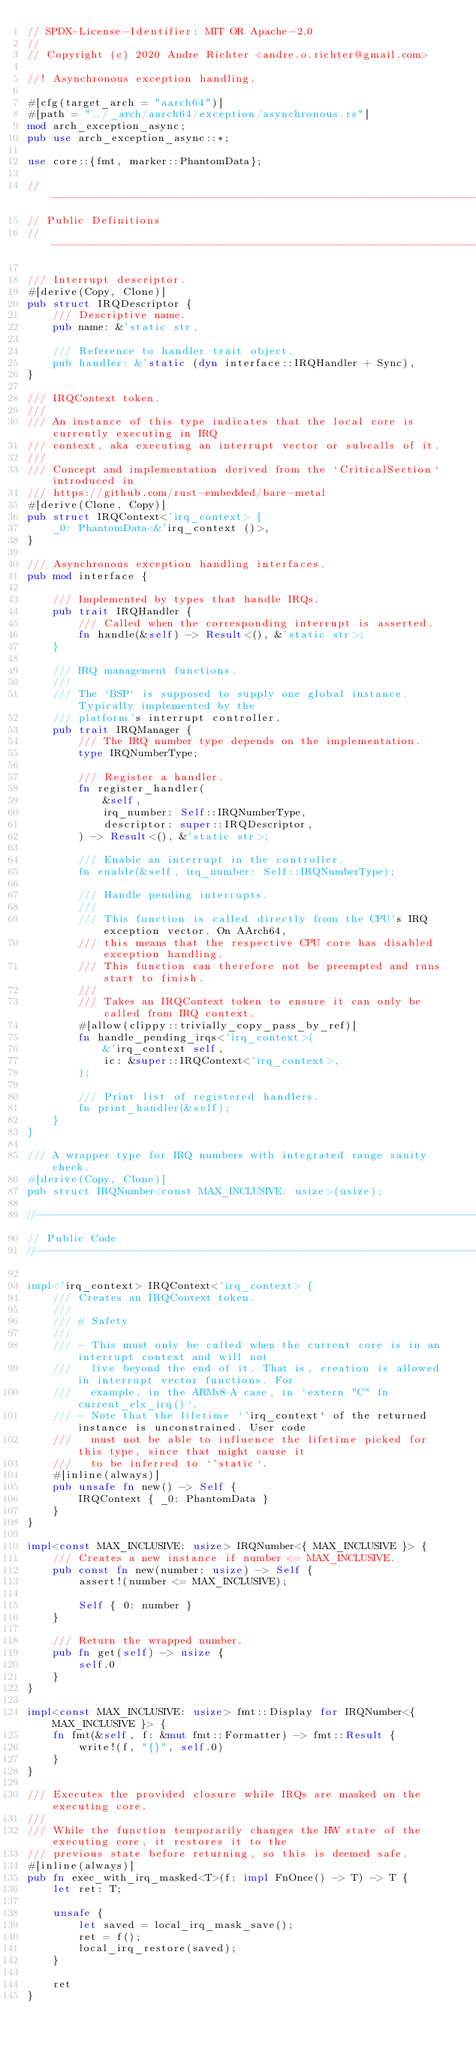Convert code to text. <code><loc_0><loc_0><loc_500><loc_500><_Rust_>// SPDX-License-Identifier: MIT OR Apache-2.0
//
// Copyright (c) 2020 Andre Richter <andre.o.richter@gmail.com>

//! Asynchronous exception handling.

#[cfg(target_arch = "aarch64")]
#[path = "../_arch/aarch64/exception/asynchronous.rs"]
mod arch_exception_async;
pub use arch_exception_async::*;

use core::{fmt, marker::PhantomData};

//--------------------------------------------------------------------------------------------------
// Public Definitions
//--------------------------------------------------------------------------------------------------

/// Interrupt descriptor.
#[derive(Copy, Clone)]
pub struct IRQDescriptor {
    /// Descriptive name.
    pub name: &'static str,

    /// Reference to handler trait object.
    pub handler: &'static (dyn interface::IRQHandler + Sync),
}

/// IRQContext token.
///
/// An instance of this type indicates that the local core is currently executing in IRQ
/// context, aka executing an interrupt vector or subcalls of it.
///
/// Concept and implementation derived from the `CriticalSection` introduced in
/// https://github.com/rust-embedded/bare-metal
#[derive(Clone, Copy)]
pub struct IRQContext<'irq_context> {
    _0: PhantomData<&'irq_context ()>,
}

/// Asynchronous exception handling interfaces.
pub mod interface {

    /// Implemented by types that handle IRQs.
    pub trait IRQHandler {
        /// Called when the corresponding interrupt is asserted.
        fn handle(&self) -> Result<(), &'static str>;
    }

    /// IRQ management functions.
    ///
    /// The `BSP` is supposed to supply one global instance. Typically implemented by the
    /// platform's interrupt controller.
    pub trait IRQManager {
        /// The IRQ number type depends on the implementation.
        type IRQNumberType;

        /// Register a handler.
        fn register_handler(
            &self,
            irq_number: Self::IRQNumberType,
            descriptor: super::IRQDescriptor,
        ) -> Result<(), &'static str>;

        /// Enable an interrupt in the controller.
        fn enable(&self, irq_number: Self::IRQNumberType);

        /// Handle pending interrupts.
        ///
        /// This function is called directly from the CPU's IRQ exception vector. On AArch64,
        /// this means that the respective CPU core has disabled exception handling.
        /// This function can therefore not be preempted and runs start to finish.
        ///
        /// Takes an IRQContext token to ensure it can only be called from IRQ context.
        #[allow(clippy::trivially_copy_pass_by_ref)]
        fn handle_pending_irqs<'irq_context>(
            &'irq_context self,
            ic: &super::IRQContext<'irq_context>,
        );

        /// Print list of registered handlers.
        fn print_handler(&self);
    }
}

/// A wrapper type for IRQ numbers with integrated range sanity check.
#[derive(Copy, Clone)]
pub struct IRQNumber<const MAX_INCLUSIVE: usize>(usize);

//--------------------------------------------------------------------------------------------------
// Public Code
//--------------------------------------------------------------------------------------------------

impl<'irq_context> IRQContext<'irq_context> {
    /// Creates an IRQContext token.
    ///
    /// # Safety
    ///
    /// - This must only be called when the current core is in an interrupt context and will not
    ///   live beyond the end of it. That is, creation is allowed in interrupt vector functions. For
    ///   example, in the ARMv8-A case, in `extern "C" fn current_elx_irq()`.
    /// - Note that the lifetime `'irq_context` of the returned instance is unconstrained. User code
    ///   must not be able to influence the lifetime picked for this type, since that might cause it
    ///   to be inferred to `'static`.
    #[inline(always)]
    pub unsafe fn new() -> Self {
        IRQContext { _0: PhantomData }
    }
}

impl<const MAX_INCLUSIVE: usize> IRQNumber<{ MAX_INCLUSIVE }> {
    /// Creates a new instance if number <= MAX_INCLUSIVE.
    pub const fn new(number: usize) -> Self {
        assert!(number <= MAX_INCLUSIVE);

        Self { 0: number }
    }

    /// Return the wrapped number.
    pub fn get(self) -> usize {
        self.0
    }
}

impl<const MAX_INCLUSIVE: usize> fmt::Display for IRQNumber<{ MAX_INCLUSIVE }> {
    fn fmt(&self, f: &mut fmt::Formatter) -> fmt::Result {
        write!(f, "{}", self.0)
    }
}

/// Executes the provided closure while IRQs are masked on the executing core.
///
/// While the function temporarily changes the HW state of the executing core, it restores it to the
/// previous state before returning, so this is deemed safe.
#[inline(always)]
pub fn exec_with_irq_masked<T>(f: impl FnOnce() -> T) -> T {
    let ret: T;

    unsafe {
        let saved = local_irq_mask_save();
        ret = f();
        local_irq_restore(saved);
    }

    ret
}
</code> 